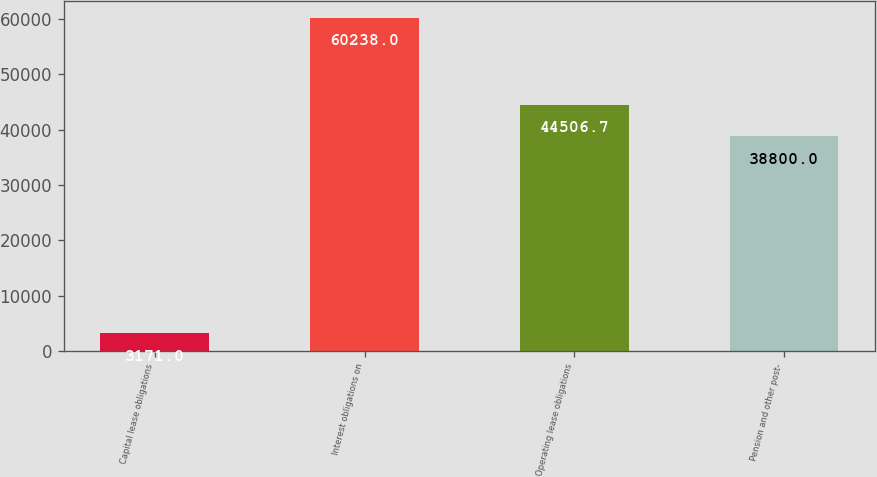Convert chart to OTSL. <chart><loc_0><loc_0><loc_500><loc_500><bar_chart><fcel>Capital lease obligations<fcel>Interest obligations on<fcel>Operating lease obligations<fcel>Pension and other post-<nl><fcel>3171<fcel>60238<fcel>44506.7<fcel>38800<nl></chart> 